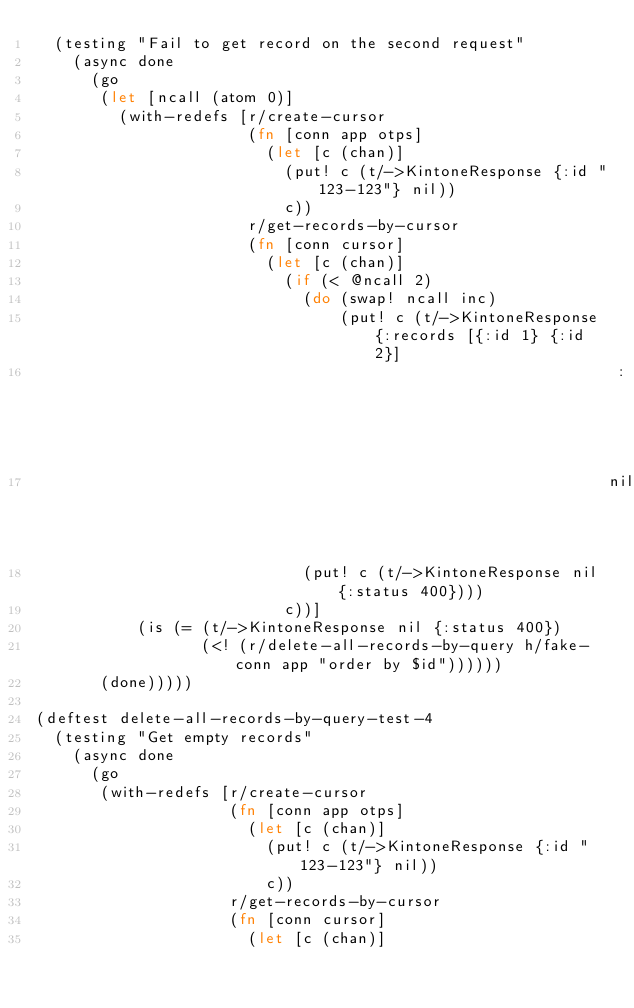Convert code to text. <code><loc_0><loc_0><loc_500><loc_500><_Clojure_>  (testing "Fail to get record on the second request"
    (async done
      (go
       (let [ncall (atom 0)]
         (with-redefs [r/create-cursor
                       (fn [conn app otps]
                         (let [c (chan)]
                           (put! c (t/->KintoneResponse {:id "123-123"} nil))
                           c))
                       r/get-records-by-cursor
                       (fn [conn cursor]
                         (let [c (chan)]
                           (if (< @ncall 2)
                             (do (swap! ncall inc)
                                 (put! c (t/->KintoneResponse {:records [{:id 1} {:id 2}]
                                                               :next true}
                                                              nil)))
                             (put! c (t/->KintoneResponse nil {:status 400})))
                           c))]
           (is (= (t/->KintoneResponse nil {:status 400})
                  (<! (r/delete-all-records-by-query h/fake-conn app "order by $id"))))))
       (done)))))

(deftest delete-all-records-by-query-test-4
  (testing "Get empty records"
    (async done
      (go
       (with-redefs [r/create-cursor
                     (fn [conn app otps]
                       (let [c (chan)]
                         (put! c (t/->KintoneResponse {:id "123-123"} nil))
                         c))
                     r/get-records-by-cursor
                     (fn [conn cursor]
                       (let [c (chan)]</code> 